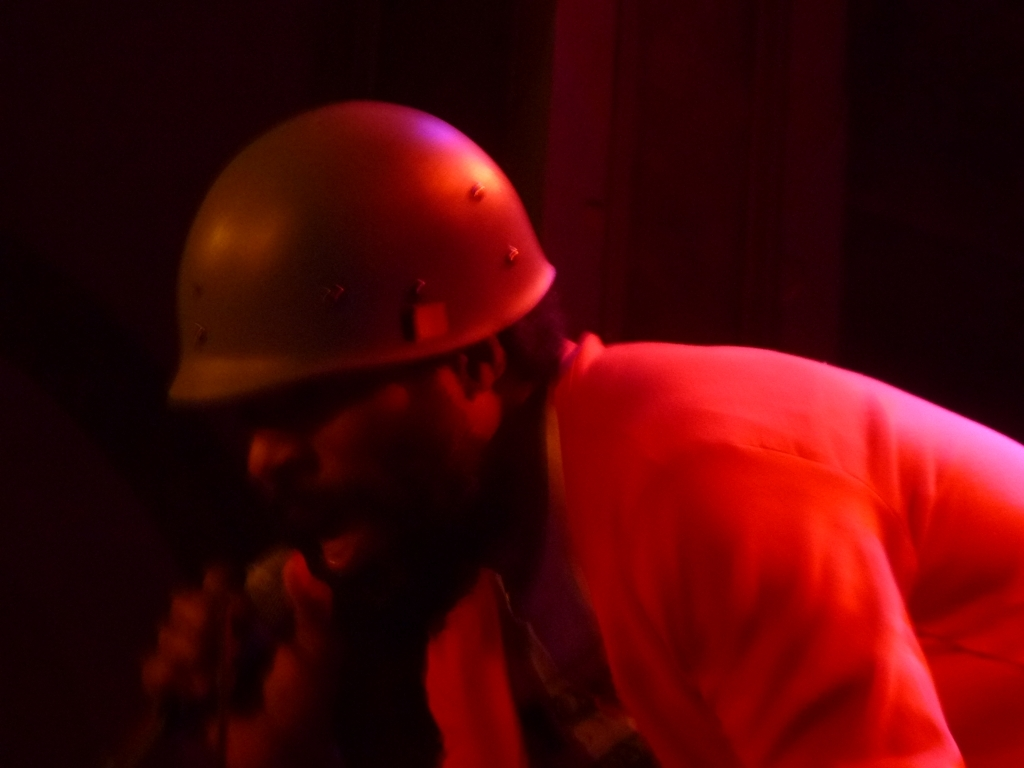What emotions does this image seem to evoke? The image appears to evoke a sense of intensity and focus, perhaps during a performance or creative expression. The warm, low lighting and the subject's concentrated expression contribute to an intimate and passionate atmosphere. 